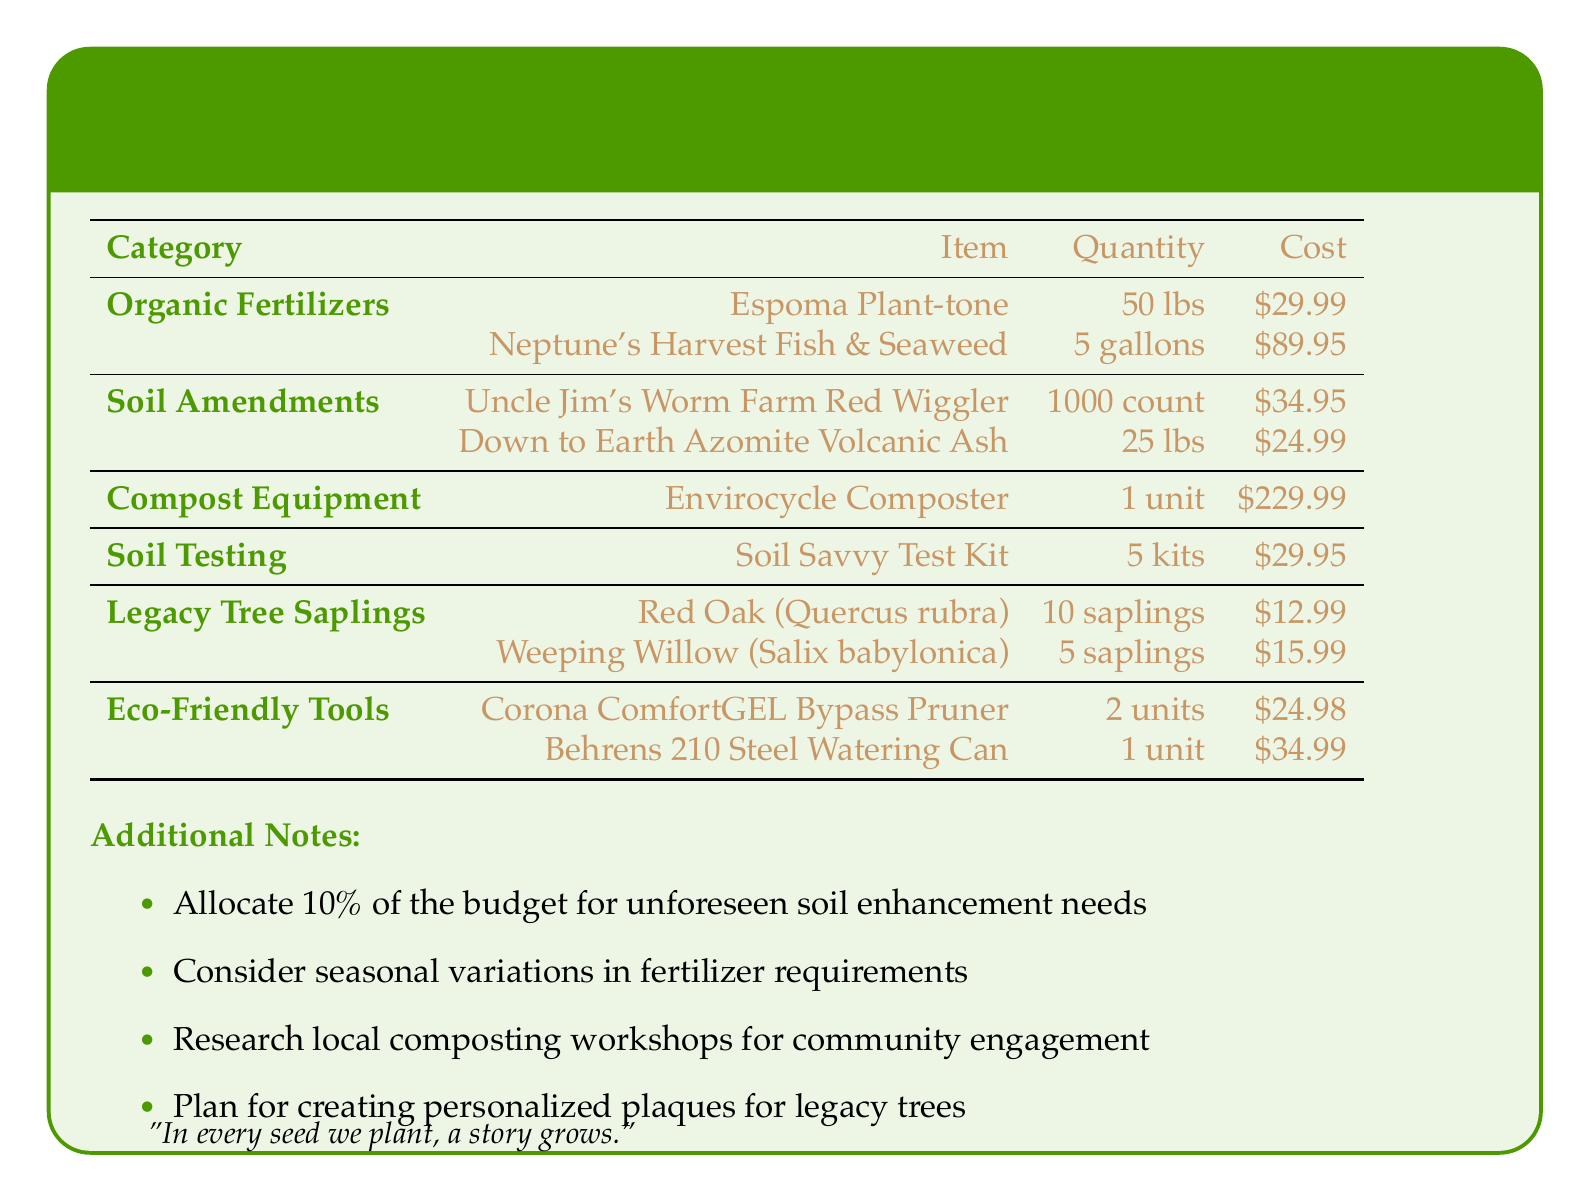What is the total cost of Organic Fertilizers? The total cost is the sum of the costs of both items under Organic Fertilizers: $29.99 + $89.95 = $119.94.
Answer: $119.94 How many Red Oak saplings are allocated? The document specifies the quantity of Red Oak saplings under Legacy Tree Saplings as 10.
Answer: 10 What item is listed under Compost Equipment? The document lists the Envirocycle Composter as the only item under Compost Equipment.
Answer: Envirocycle Composter What percentage of the budget is allocated for unforeseen soil enhancement needs? The document states that 10% of the budget should be allocated for unforeseen soil enhancement needs.
Answer: 10% How many soil testing kits are included in the budget? The quantity of Soil Savvy Test Kits is explicitly stated as 5 kits in the table.
Answer: 5 kits 